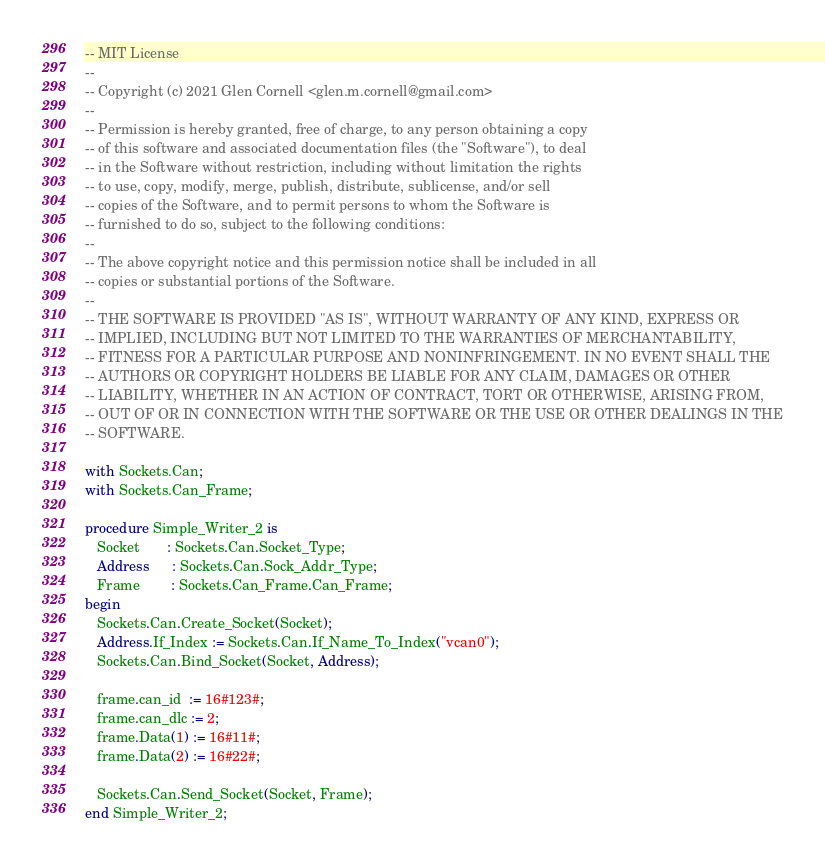<code> <loc_0><loc_0><loc_500><loc_500><_Ada_>-- MIT License
--
-- Copyright (c) 2021 Glen Cornell <glen.m.cornell@gmail.com>
--
-- Permission is hereby granted, free of charge, to any person obtaining a copy
-- of this software and associated documentation files (the "Software"), to deal
-- in the Software without restriction, including without limitation the rights
-- to use, copy, modify, merge, publish, distribute, sublicense, and/or sell
-- copies of the Software, and to permit persons to whom the Software is
-- furnished to do so, subject to the following conditions:
--
-- The above copyright notice and this permission notice shall be included in all
-- copies or substantial portions of the Software.
--
-- THE SOFTWARE IS PROVIDED "AS IS", WITHOUT WARRANTY OF ANY KIND, EXPRESS OR
-- IMPLIED, INCLUDING BUT NOT LIMITED TO THE WARRANTIES OF MERCHANTABILITY,
-- FITNESS FOR A PARTICULAR PURPOSE AND NONINFRINGEMENT. IN NO EVENT SHALL THE
-- AUTHORS OR COPYRIGHT HOLDERS BE LIABLE FOR ANY CLAIM, DAMAGES OR OTHER
-- LIABILITY, WHETHER IN AN ACTION OF CONTRACT, TORT OR OTHERWISE, ARISING FROM,
-- OUT OF OR IN CONNECTION WITH THE SOFTWARE OR THE USE OR OTHER DEALINGS IN THE
-- SOFTWARE.

with Sockets.Can;
with Sockets.Can_Frame;

procedure Simple_Writer_2 is
   Socket       : Sockets.Can.Socket_Type;
   Address      : Sockets.Can.Sock_Addr_Type;
   Frame        : Sockets.Can_Frame.Can_Frame;
begin
   Sockets.Can.Create_Socket(Socket);
   Address.If_Index := Sockets.Can.If_Name_To_Index("vcan0");
   Sockets.Can.Bind_Socket(Socket, Address);
   
   frame.can_id  := 16#123#;
   frame.can_dlc := 2;
   frame.Data(1) := 16#11#;
   frame.Data(2) := 16#22#;
   
   Sockets.Can.Send_Socket(Socket, Frame);
end Simple_Writer_2;
</code> 